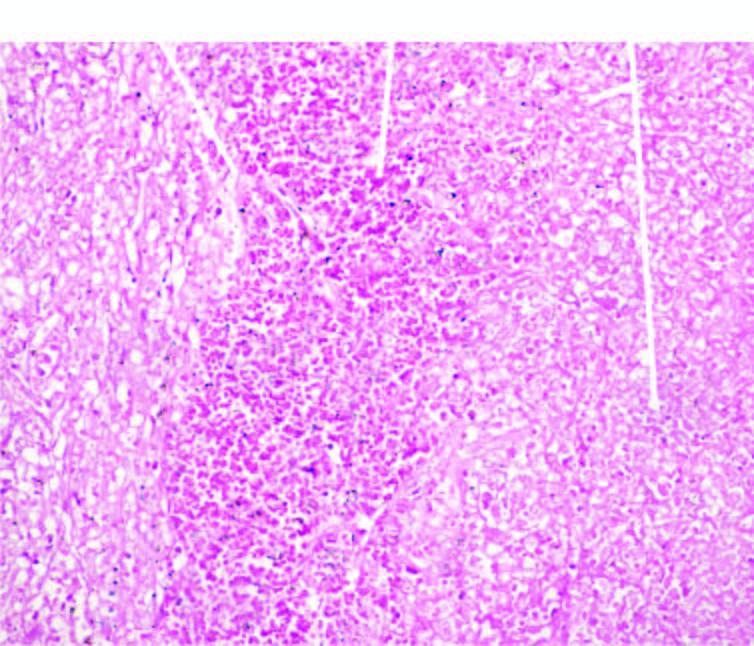does the sectioned surface show haemorrhage?
Answer the question using a single word or phrase. No 